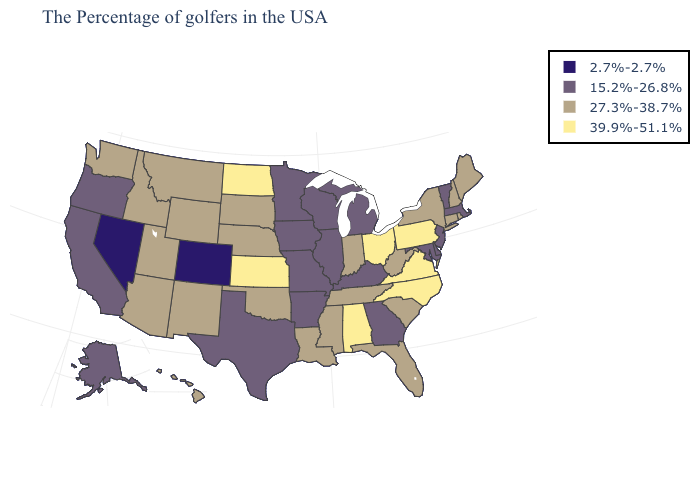What is the value of Maryland?
Keep it brief. 15.2%-26.8%. Name the states that have a value in the range 39.9%-51.1%?
Give a very brief answer. Pennsylvania, Virginia, North Carolina, Ohio, Alabama, Kansas, North Dakota. Among the states that border Illinois , which have the highest value?
Be succinct. Indiana. What is the highest value in the USA?
Be succinct. 39.9%-51.1%. Among the states that border New Hampshire , does Vermont have the lowest value?
Concise answer only. Yes. What is the highest value in the South ?
Be succinct. 39.9%-51.1%. Does the first symbol in the legend represent the smallest category?
Quick response, please. Yes. Name the states that have a value in the range 2.7%-2.7%?
Answer briefly. Colorado, Nevada. Name the states that have a value in the range 39.9%-51.1%?
Short answer required. Pennsylvania, Virginia, North Carolina, Ohio, Alabama, Kansas, North Dakota. Which states have the lowest value in the South?
Write a very short answer. Delaware, Maryland, Georgia, Kentucky, Arkansas, Texas. Name the states that have a value in the range 2.7%-2.7%?
Concise answer only. Colorado, Nevada. Name the states that have a value in the range 39.9%-51.1%?
Give a very brief answer. Pennsylvania, Virginia, North Carolina, Ohio, Alabama, Kansas, North Dakota. Name the states that have a value in the range 2.7%-2.7%?
Give a very brief answer. Colorado, Nevada. What is the value of Illinois?
Answer briefly. 15.2%-26.8%. What is the value of Montana?
Be succinct. 27.3%-38.7%. 